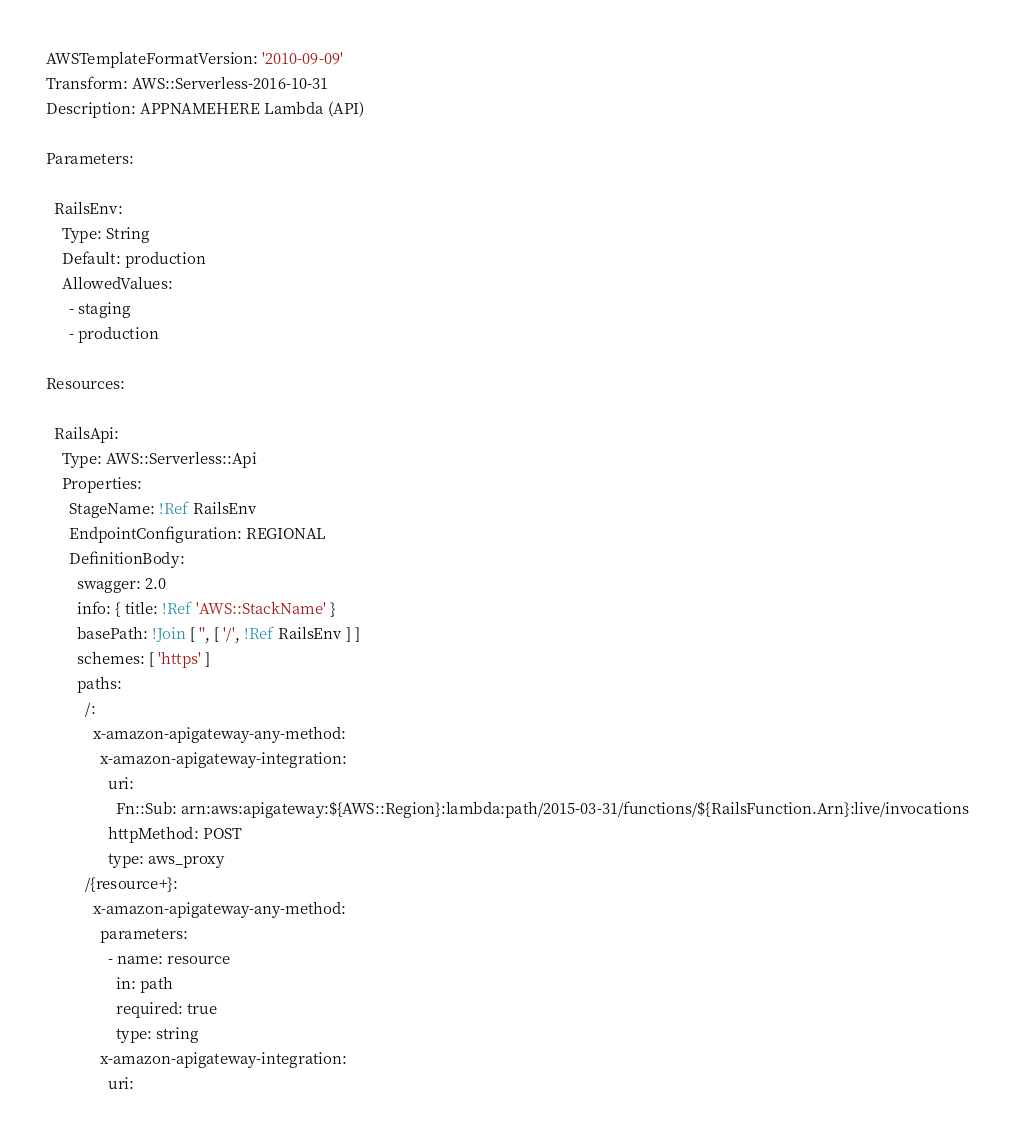<code> <loc_0><loc_0><loc_500><loc_500><_YAML_>AWSTemplateFormatVersion: '2010-09-09'
Transform: AWS::Serverless-2016-10-31
Description: APPNAMEHERE Lambda (API)

Parameters:

  RailsEnv:
    Type: String
    Default: production
    AllowedValues:
      - staging
      - production

Resources:

  RailsApi:
    Type: AWS::Serverless::Api
    Properties:
      StageName: !Ref RailsEnv
      EndpointConfiguration: REGIONAL
      DefinitionBody:
        swagger: 2.0
        info: { title: !Ref 'AWS::StackName' }
        basePath: !Join [ '', [ '/', !Ref RailsEnv ] ]
        schemes: [ 'https' ]
        paths:
          /:
            x-amazon-apigateway-any-method:
              x-amazon-apigateway-integration:
                uri:
                  Fn::Sub: arn:aws:apigateway:${AWS::Region}:lambda:path/2015-03-31/functions/${RailsFunction.Arn}:live/invocations
                httpMethod: POST
                type: aws_proxy
          /{resource+}:
            x-amazon-apigateway-any-method:
              parameters:
                - name: resource
                  in: path
                  required: true
                  type: string
              x-amazon-apigateway-integration:
                uri:</code> 